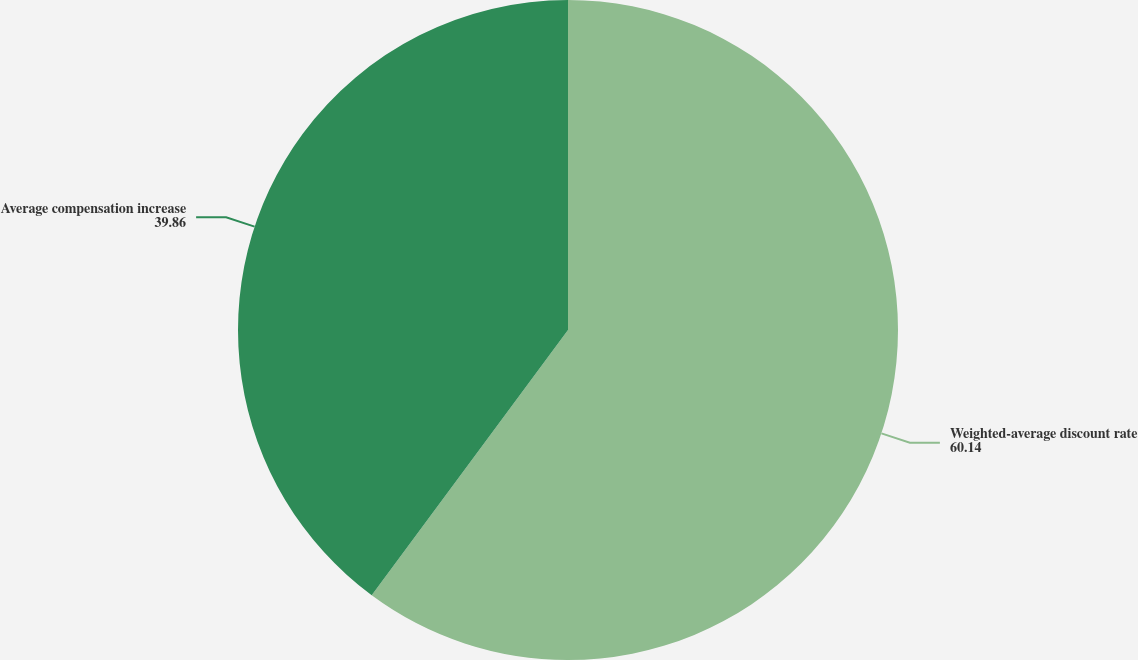Convert chart. <chart><loc_0><loc_0><loc_500><loc_500><pie_chart><fcel>Weighted-average discount rate<fcel>Average compensation increase<nl><fcel>60.14%<fcel>39.86%<nl></chart> 